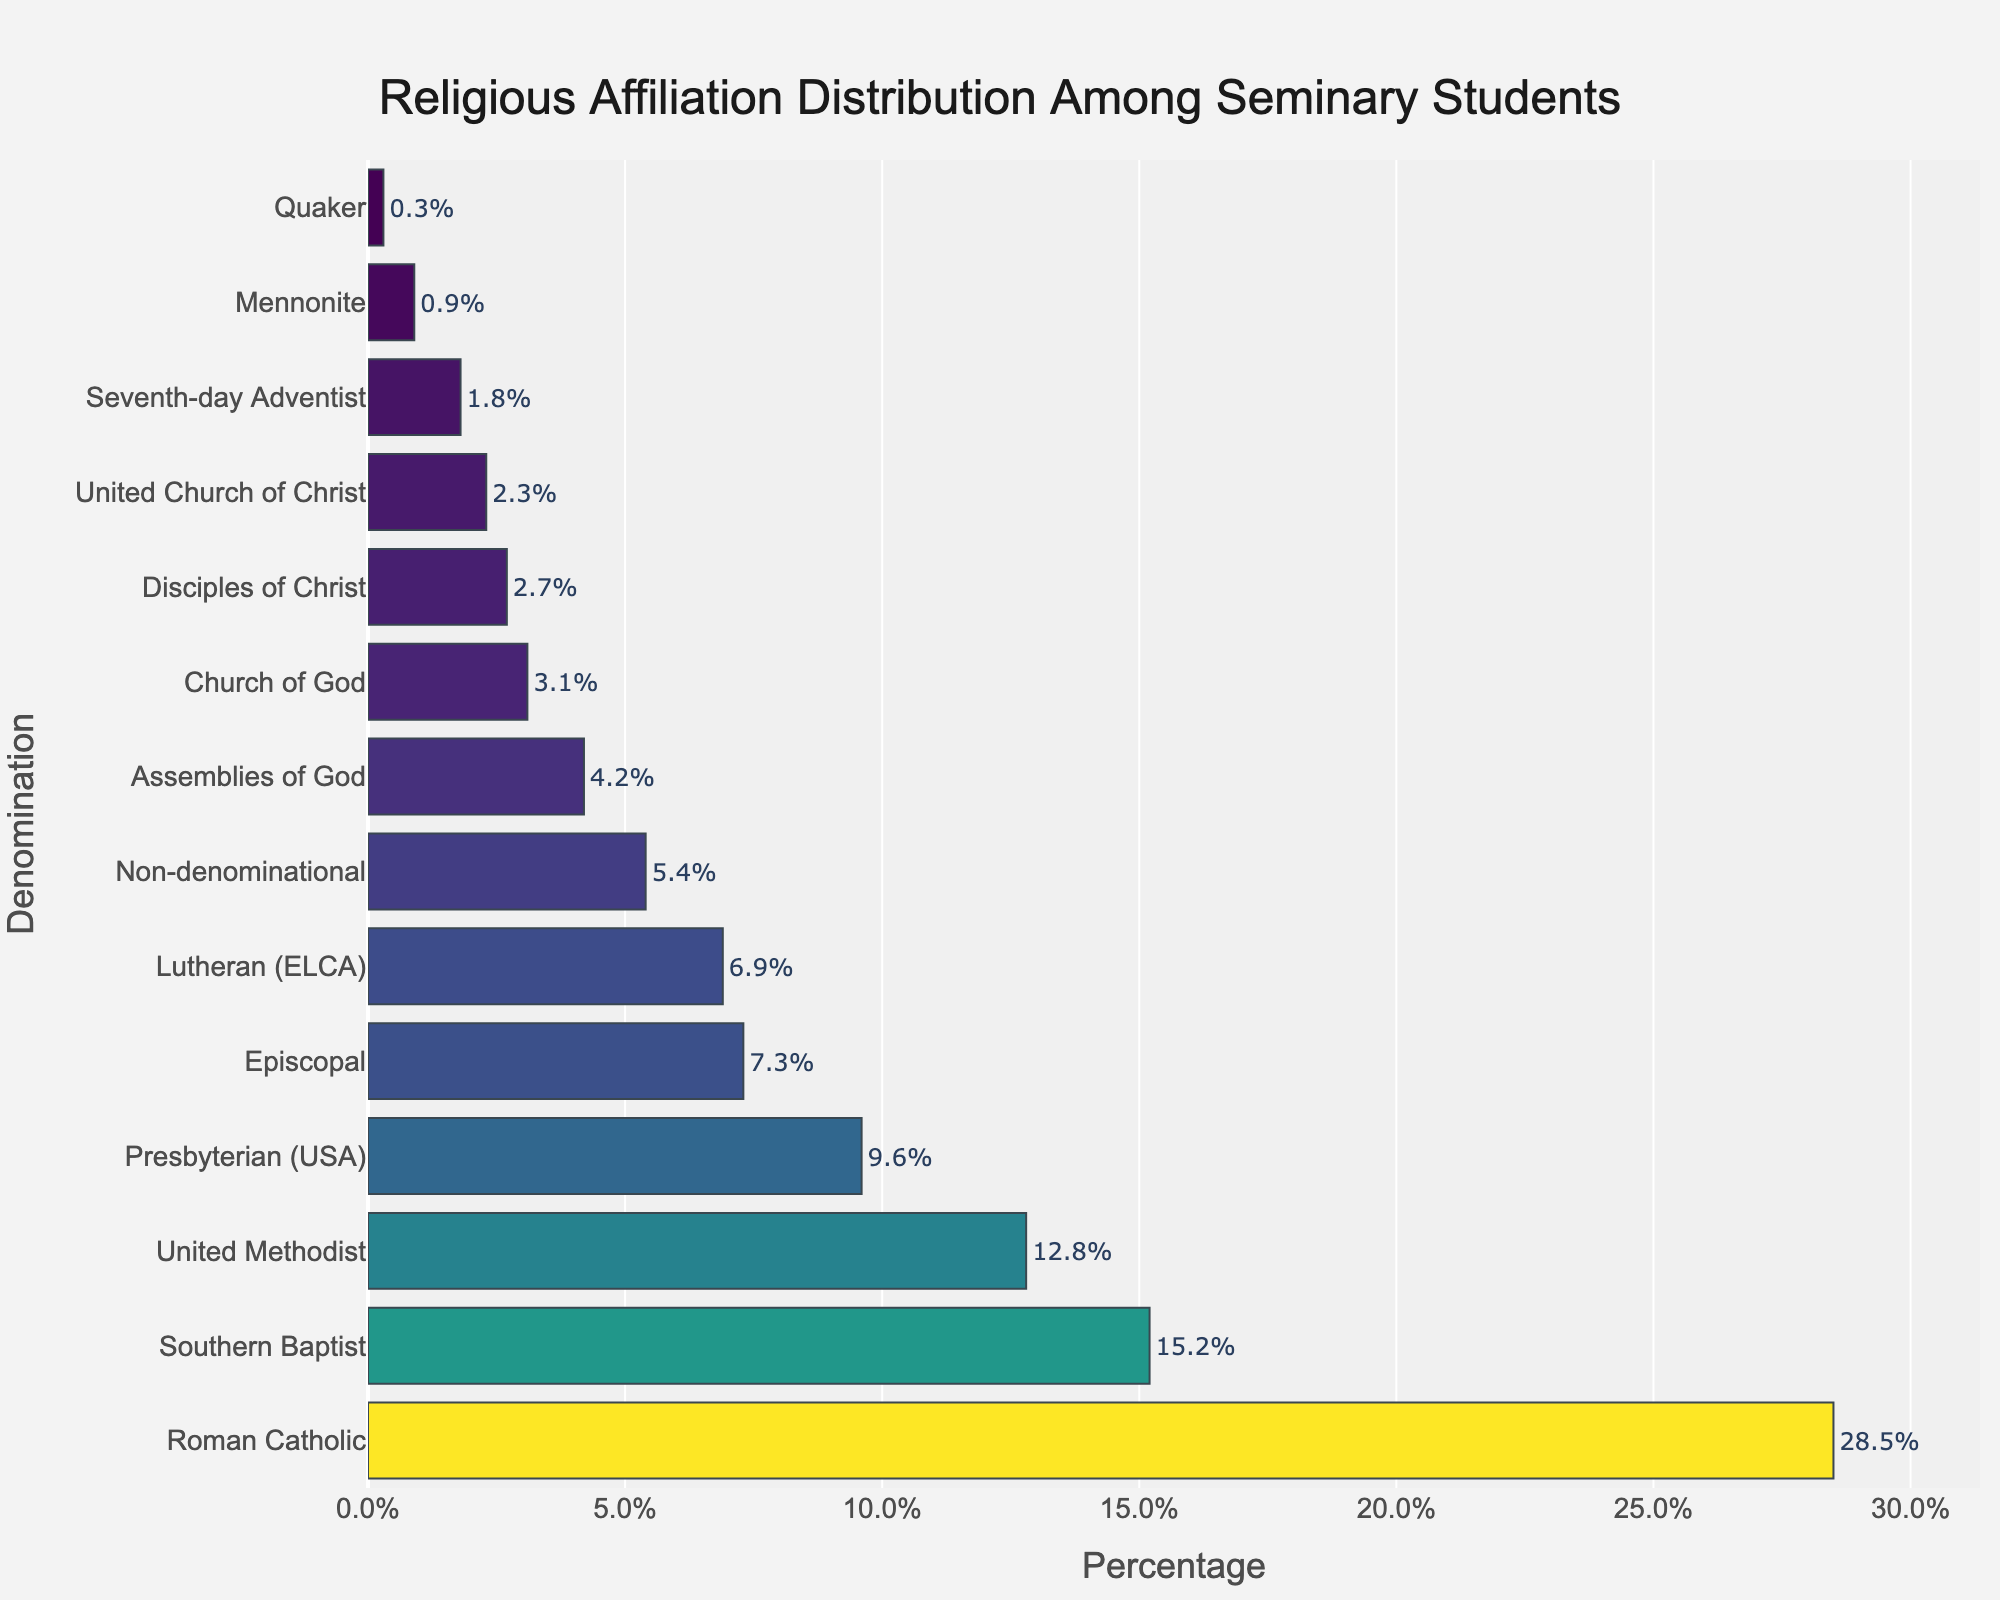What's the percentage of Roman Catholic seminary students? The Roman Catholic denomination is shown at the top of the chart. The bar corresponding to Roman Catholic has a label indicating its percentage value.
Answer: 28.5% Which denomination has the lowest percentage of seminary students? To find the denomination with the lowest percentage, look at the bar closest to the bottom of the chart. The label next to this bar is "Quaker," and its percentage is 0.3%.
Answer: Quaker How much higher is the percentage of Southern Baptist students compared to United Methodist students? First, find the percentage of Southern Baptist students (15.2%) and United Methodist students (12.8%). Subtract the latter from the former: 15.2% - 12.8% = 2.4%.
Answer: 2.4% What's the combined percentage of students affiliated with Presbyterian (USA) and Episcopal denominations? Find the percentage for Presbyterian (USA) (9.6%) and Episcopal (7.3%). Add them together: 9.6% + 7.3% = 16.9%.
Answer: 16.9% Which denomination is more represented: Assemblies of God or Church of God? Compare the bars for Assemblies of God (4.2%) and Church of God (3.1%). The Assemblies of God has a higher percentage.
Answer: Assemblies of God What's the visual cue that indicates the highest percentage in the chart? The highest percentage will be represented by the longest bar in the chart. The Roman Catholic denomination has the longest bar.
Answer: Longest bar What is the percentage difference between the highest and the lowest denominations? First, find the highest percentage (Roman Catholic: 28.5%) and the lowest percentage (Quaker: 0.3%). Subtract the latter from the former: 28.5% - 0.3% = 28.2%.
Answer: 28.2% Which denominations have a percentage greater than 10%? Identify all the bars with a length that marks a percentage above 10%. These denominations are Roman Catholic, Southern Baptist, and United Methodist.
Answer: Roman Catholic, Southern Baptist, United Methodist What is the average percentage of students in the Non-denominational, Assemblies of God, and Church of God denominations? Find the individual percentages: Non-denominational (5.4%), Assemblies of God (4.2%), and Church of God (3.1%). Sum them up: 5.4 + 4.2 + 3.1 = 12.7 and then divide by 3: 12.7 / 3 ≈ 4.23%.
Answer: 4.23% How do Lutheran (ELCA) students compare percentage-wise to United Church of Christ students? Compare the percentages of Lutheran (ELCA) (6.9%) and United Church of Christ (2.3%). Lutheran (ELCA) has a higher value.
Answer: Lutheran (ELCA) 